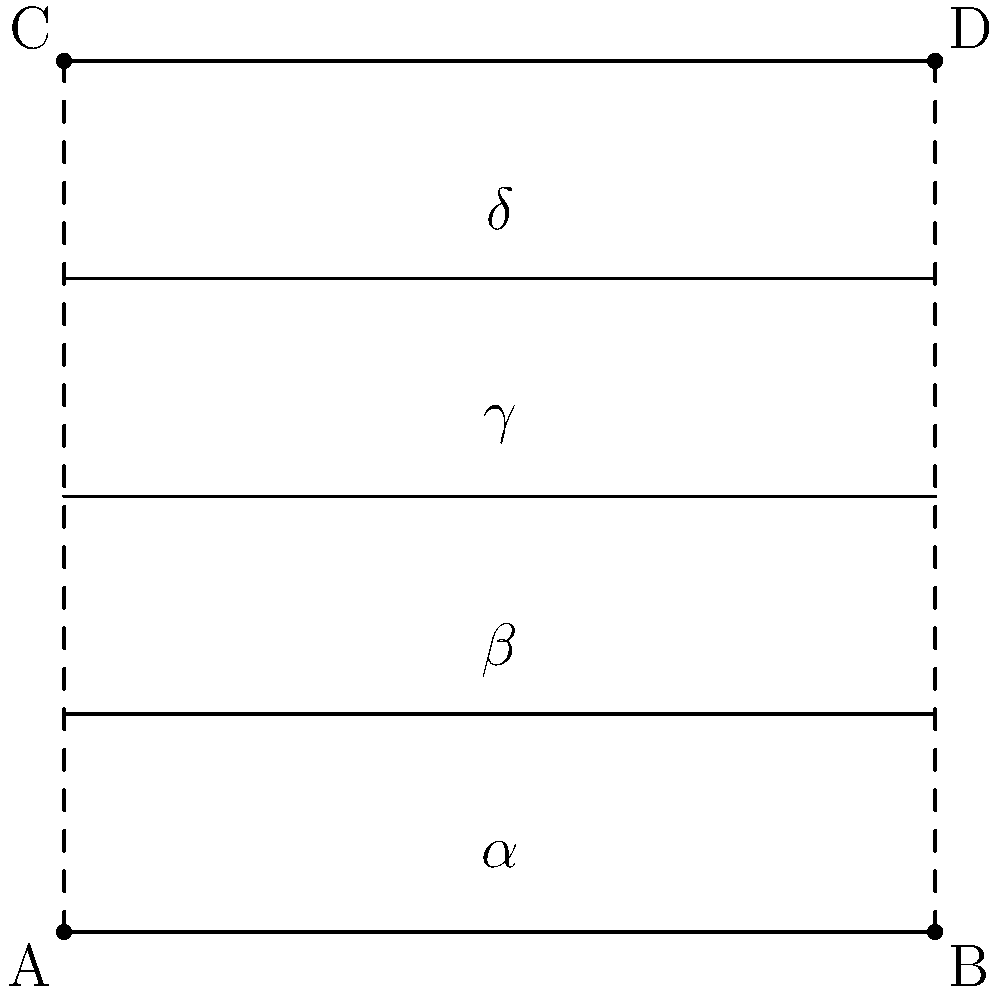In a musical staff diagram, five equally spaced horizontal lines are intersected by two diagonal lines forming a series of angles. If the angle $\alpha$ at the bottom is 15°, what is the value of angle $\delta$ at the top? Let's approach this step-by-step:

1) First, we need to recognize that the five horizontal lines are equally spaced, creating four equal sections.

2) The two diagonal lines are straight, so they form corresponding angles with each horizontal line they intersect.

3) In a straight line, angles on the same side of a transversal are supplementary. This means $\alpha + \beta = 180°$.

4) Since the spacing is equal, we know that $\alpha = \beta = \gamma = \delta$.

5) Let's call this common angle $x$. We can now write an equation:
   $x + x = 180°$
   $2x = 180°$
   $x = 90°$

6) We're told that $\alpha = 15°$. This means that the angle formed by the intersection of the diagonals is $90° - 15° = 75°$.

7) As we move up the staff, each angle increases by this 75°:
   $\beta = 15° + 75° = 90°$
   $\gamma = 90° + 75° = 165°$
   $\delta = 165° + 75° = 240°$

8) However, angles are typically expressed as less than or equal to 180°. So we need to subtract 180° from our result:
   $\delta = 240° - 180° = 60°$

Therefore, the value of angle $\delta$ at the top is 60°.
Answer: 60° 